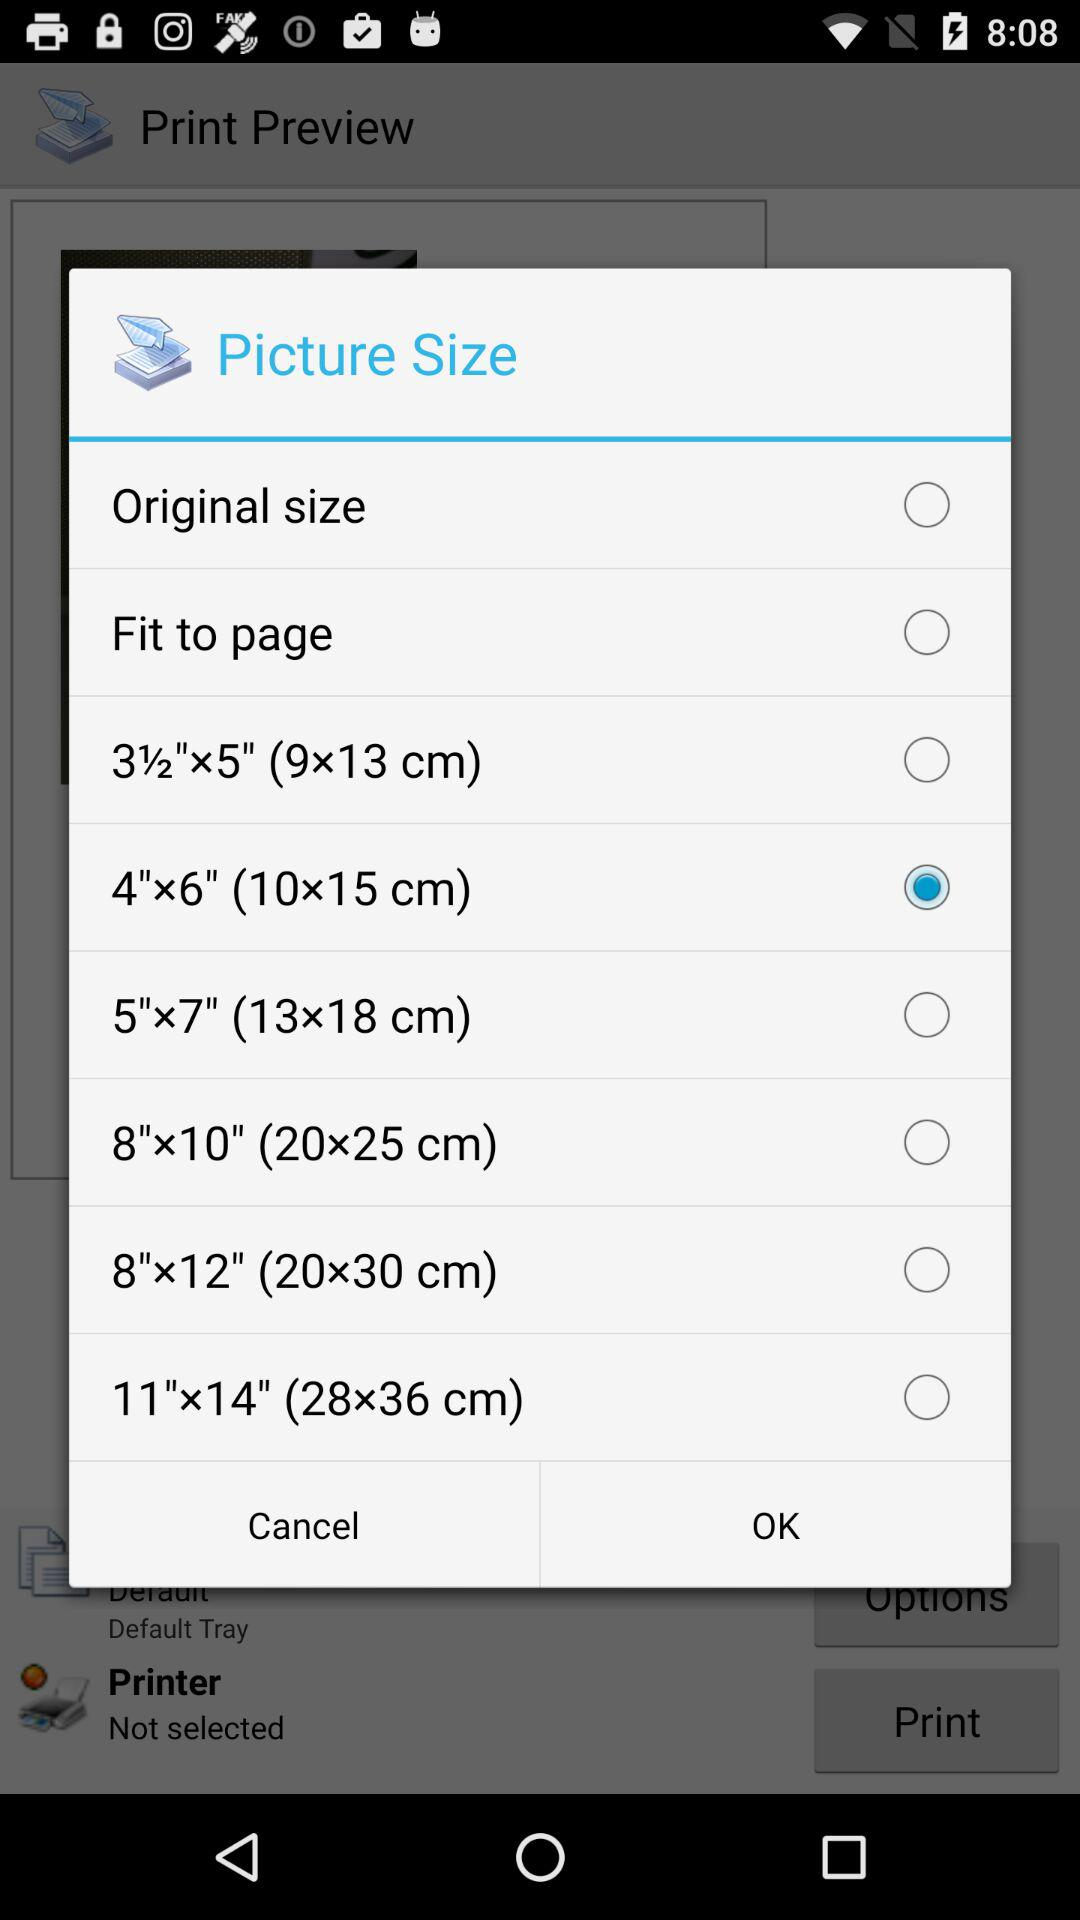Which picture size is selected? The selected picture size is "4"x6" (10x15 cm)". 